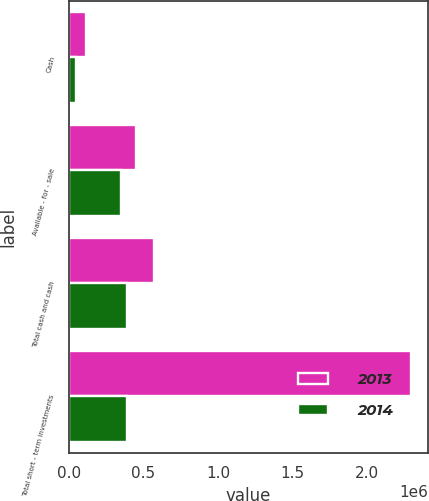Convert chart to OTSL. <chart><loc_0><loc_0><loc_500><loc_500><stacked_bar_chart><ecel><fcel>Cash<fcel>Available - for - sale<fcel>Total cash and cash<fcel>Total short - term investments<nl><fcel>2013<fcel>117337<fcel>447968<fcel>569233<fcel>2.29724e+06<nl><fcel>2014<fcel>45637<fcel>346452<fcel>392089<fcel>392089<nl></chart> 